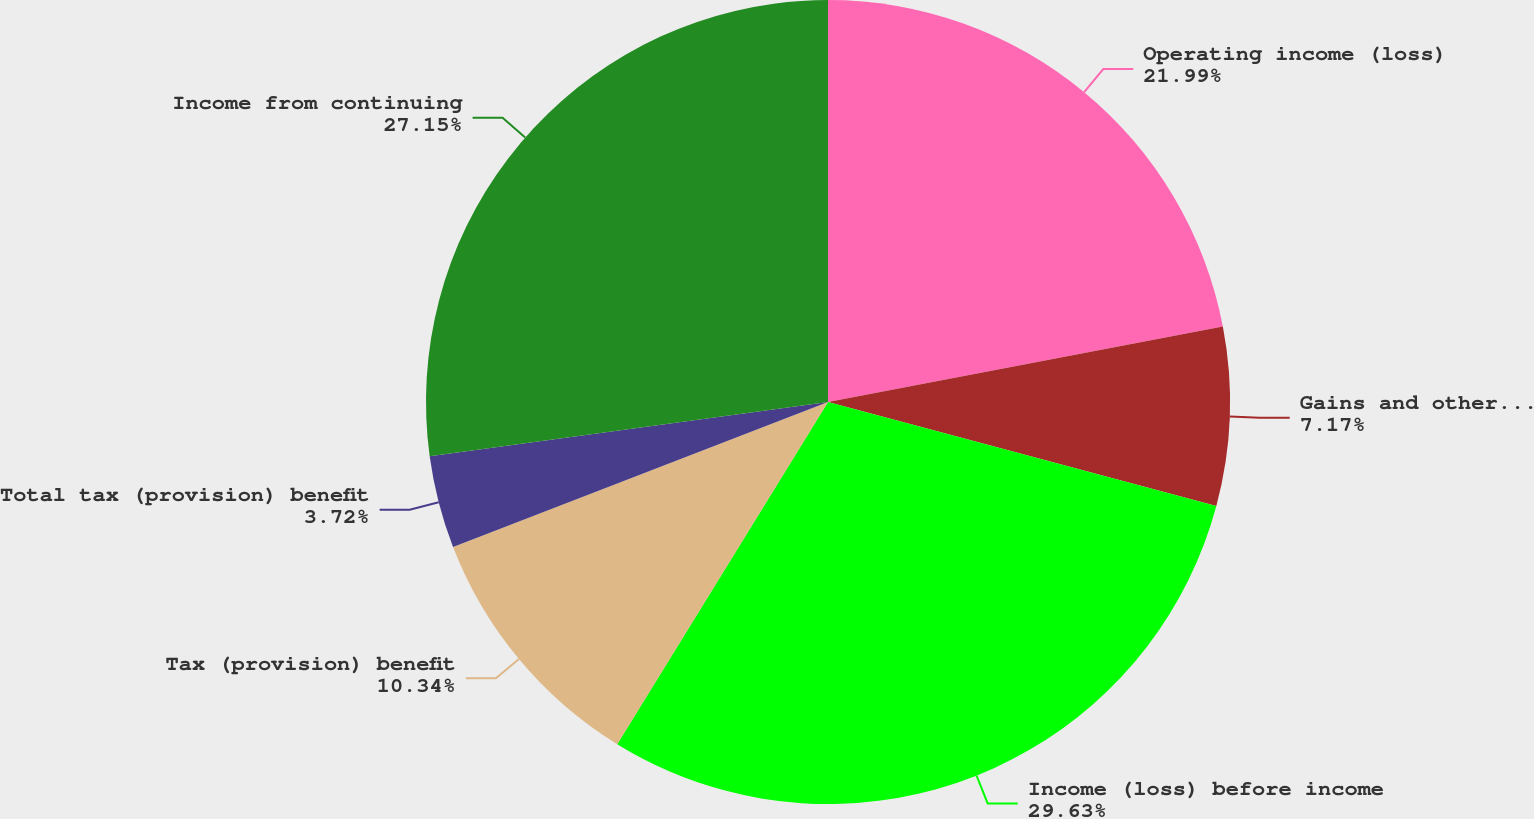<chart> <loc_0><loc_0><loc_500><loc_500><pie_chart><fcel>Operating income (loss)<fcel>Gains and other income<fcel>Income (loss) before income<fcel>Tax (provision) benefit<fcel>Total tax (provision) benefit<fcel>Income from continuing<nl><fcel>21.99%<fcel>7.17%<fcel>29.62%<fcel>10.34%<fcel>3.72%<fcel>27.15%<nl></chart> 